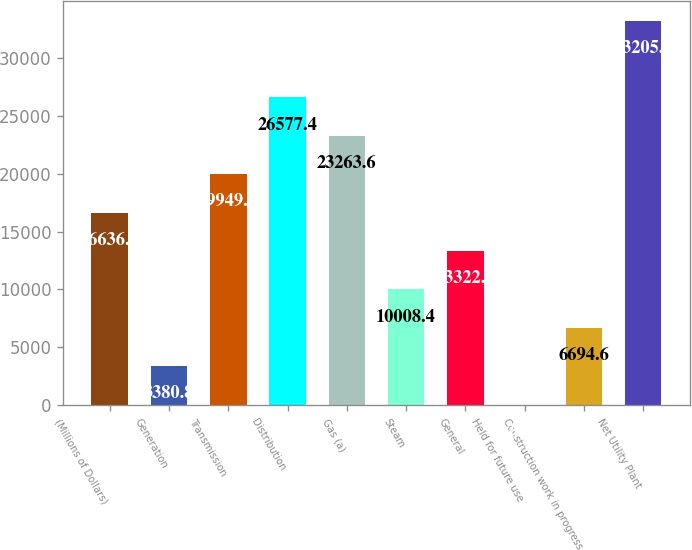<chart> <loc_0><loc_0><loc_500><loc_500><bar_chart><fcel>(Millions of Dollars)<fcel>Generation<fcel>Transmission<fcel>Distribution<fcel>Gas (a)<fcel>Steam<fcel>General<fcel>Held for future use<fcel>Construction work in progress<fcel>Net Utility Plant<nl><fcel>16636<fcel>3380.8<fcel>19949.8<fcel>26577.4<fcel>23263.6<fcel>10008.4<fcel>13322.2<fcel>67<fcel>6694.6<fcel>33205<nl></chart> 